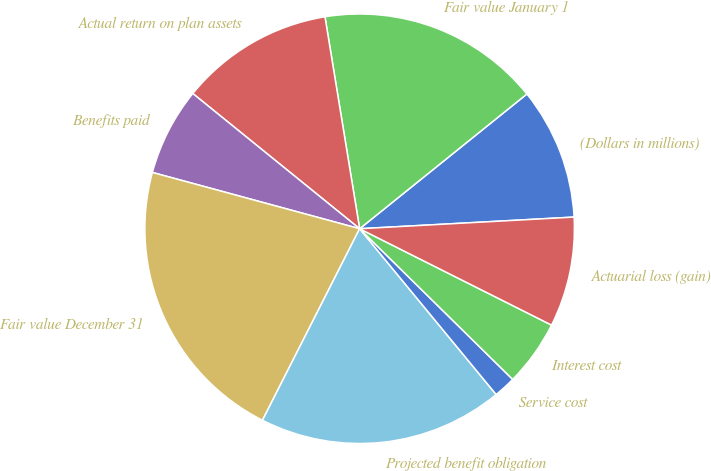Convert chart. <chart><loc_0><loc_0><loc_500><loc_500><pie_chart><fcel>(Dollars in millions)<fcel>Fair value January 1<fcel>Actual return on plan assets<fcel>Benefits paid<fcel>Fair value December 31<fcel>Projected benefit obligation<fcel>Service cost<fcel>Interest cost<fcel>Actuarial loss (gain)<nl><fcel>9.93%<fcel>16.79%<fcel>11.58%<fcel>6.62%<fcel>21.75%<fcel>18.44%<fcel>1.66%<fcel>4.97%<fcel>8.27%<nl></chart> 